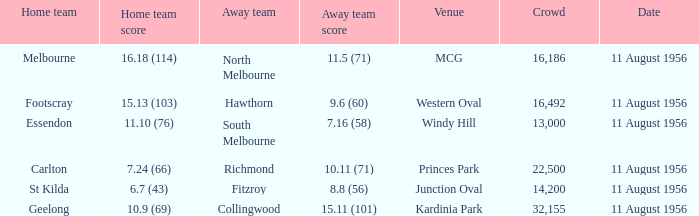What home team played at western oval? Footscray. 